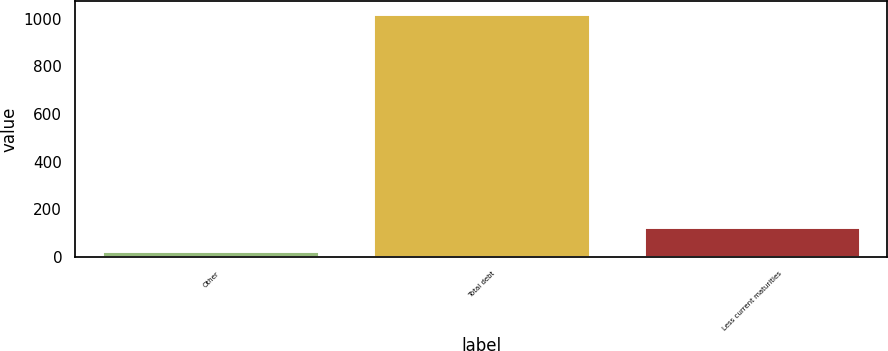Convert chart to OTSL. <chart><loc_0><loc_0><loc_500><loc_500><bar_chart><fcel>Other<fcel>Total debt<fcel>Less current maturities<nl><fcel>25.3<fcel>1021.8<fcel>124.95<nl></chart> 